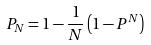<formula> <loc_0><loc_0><loc_500><loc_500>P _ { N } = 1 - \frac { 1 } { N } \left ( 1 - P ^ { N } \right )</formula> 